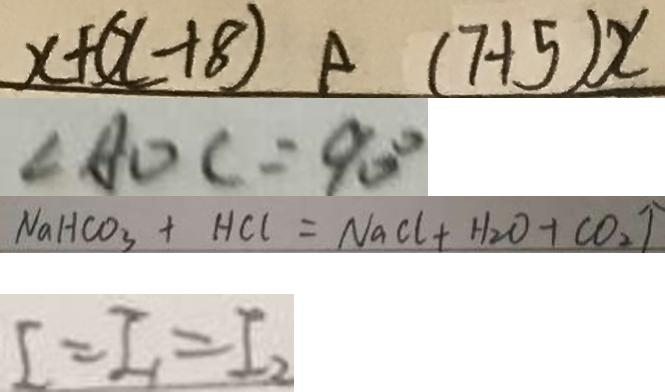<formula> <loc_0><loc_0><loc_500><loc_500>x + ( x + 8 ) ( 7 + 5 ) x 
 \angle A O C = 9 0 ^ { \circ } 
 N a H C O _ { 3 } + H C l = N a C l + H _ { 2 } O + C O _ { 2 } \uparrow 
 I = I _ { 1 } = I _ { 2 }</formula> 